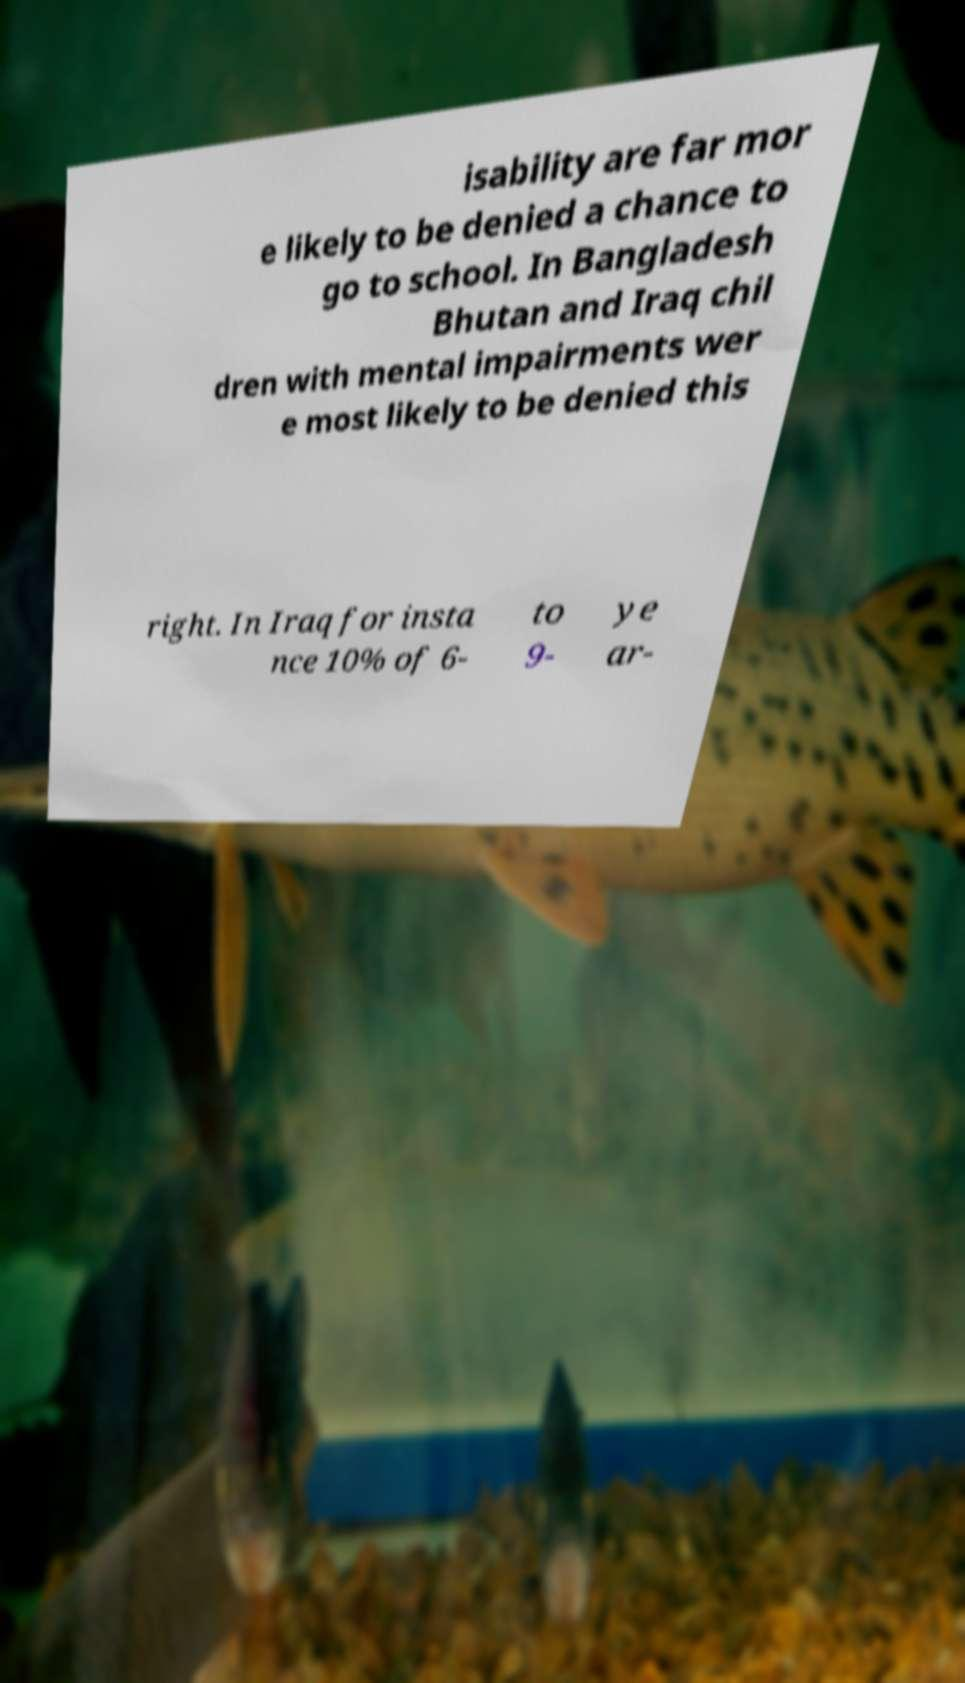For documentation purposes, I need the text within this image transcribed. Could you provide that? isability are far mor e likely to be denied a chance to go to school. In Bangladesh Bhutan and Iraq chil dren with mental impairments wer e most likely to be denied this right. In Iraq for insta nce 10% of 6- to 9- ye ar- 